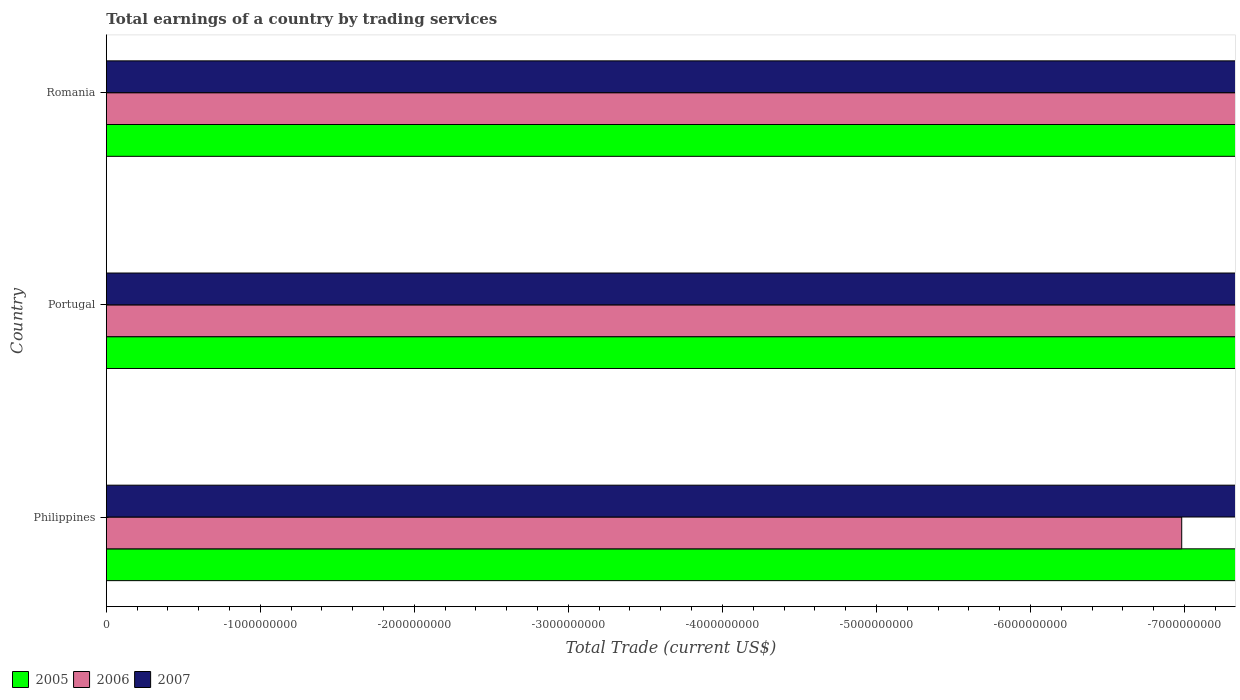How many different coloured bars are there?
Your answer should be very brief. 0. What is the label of the 3rd group of bars from the top?
Your answer should be compact. Philippines. In how many cases, is the number of bars for a given country not equal to the number of legend labels?
Offer a terse response. 3. What is the total earnings in 2007 in Romania?
Your answer should be compact. 0. Across all countries, what is the minimum total earnings in 2005?
Keep it short and to the point. 0. What is the total total earnings in 2005 in the graph?
Ensure brevity in your answer.  0. What is the difference between the total earnings in 2006 in Philippines and the total earnings in 2007 in Portugal?
Your answer should be compact. 0. What is the average total earnings in 2007 per country?
Your answer should be compact. 0. In how many countries, is the total earnings in 2006 greater than -1600000000 US$?
Provide a succinct answer. 0. In how many countries, is the total earnings in 2006 greater than the average total earnings in 2006 taken over all countries?
Make the answer very short. 0. Is it the case that in every country, the sum of the total earnings in 2006 and total earnings in 2007 is greater than the total earnings in 2005?
Your response must be concise. No. What is the difference between two consecutive major ticks on the X-axis?
Your answer should be very brief. 1.00e+09. Are the values on the major ticks of X-axis written in scientific E-notation?
Provide a short and direct response. No. Does the graph contain any zero values?
Your response must be concise. Yes. How are the legend labels stacked?
Ensure brevity in your answer.  Horizontal. What is the title of the graph?
Ensure brevity in your answer.  Total earnings of a country by trading services. What is the label or title of the X-axis?
Make the answer very short. Total Trade (current US$). What is the Total Trade (current US$) of 2006 in Philippines?
Make the answer very short. 0. What is the Total Trade (current US$) of 2006 in Portugal?
Your answer should be compact. 0. What is the Total Trade (current US$) of 2007 in Portugal?
Keep it short and to the point. 0. What is the Total Trade (current US$) of 2006 in Romania?
Provide a short and direct response. 0. What is the total Total Trade (current US$) of 2005 in the graph?
Your response must be concise. 0. What is the total Total Trade (current US$) of 2006 in the graph?
Offer a terse response. 0. 